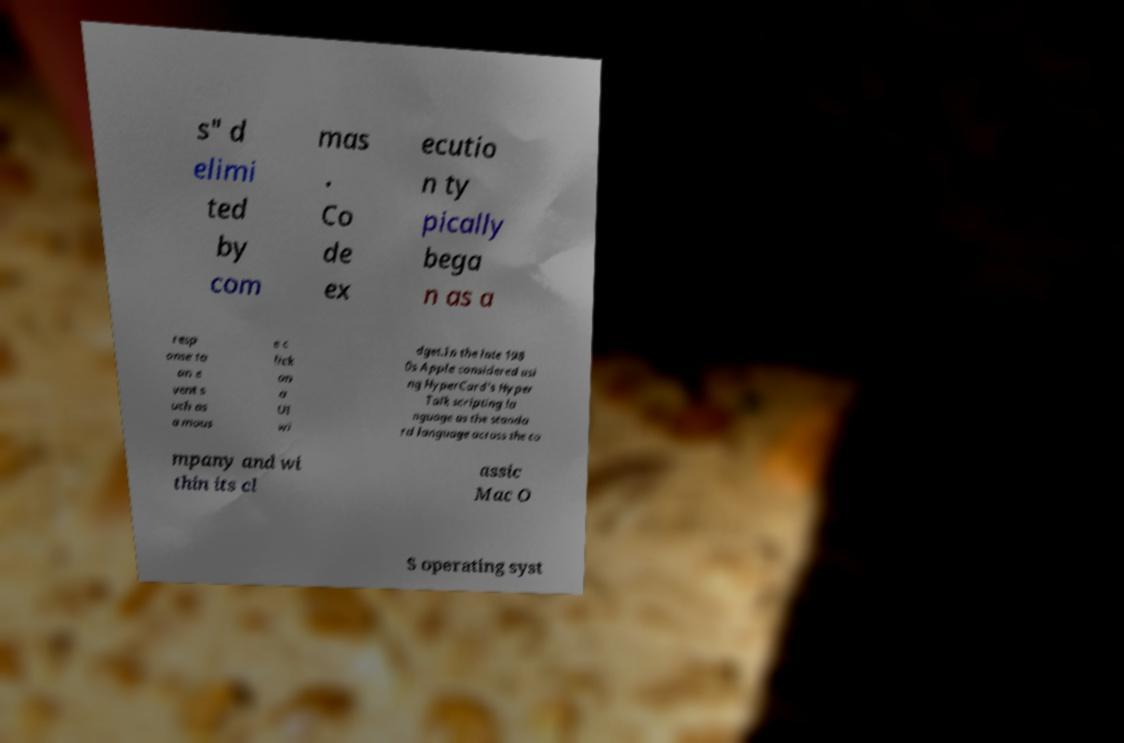For documentation purposes, I need the text within this image transcribed. Could you provide that? s" d elimi ted by com mas . Co de ex ecutio n ty pically bega n as a resp onse to an e vent s uch as a mous e c lick on a UI wi dget.In the late 198 0s Apple considered usi ng HyperCard's Hyper Talk scripting la nguage as the standa rd language across the co mpany and wi thin its cl assic Mac O S operating syst 